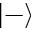<formula> <loc_0><loc_0><loc_500><loc_500>\left | - \right \rangle</formula> 